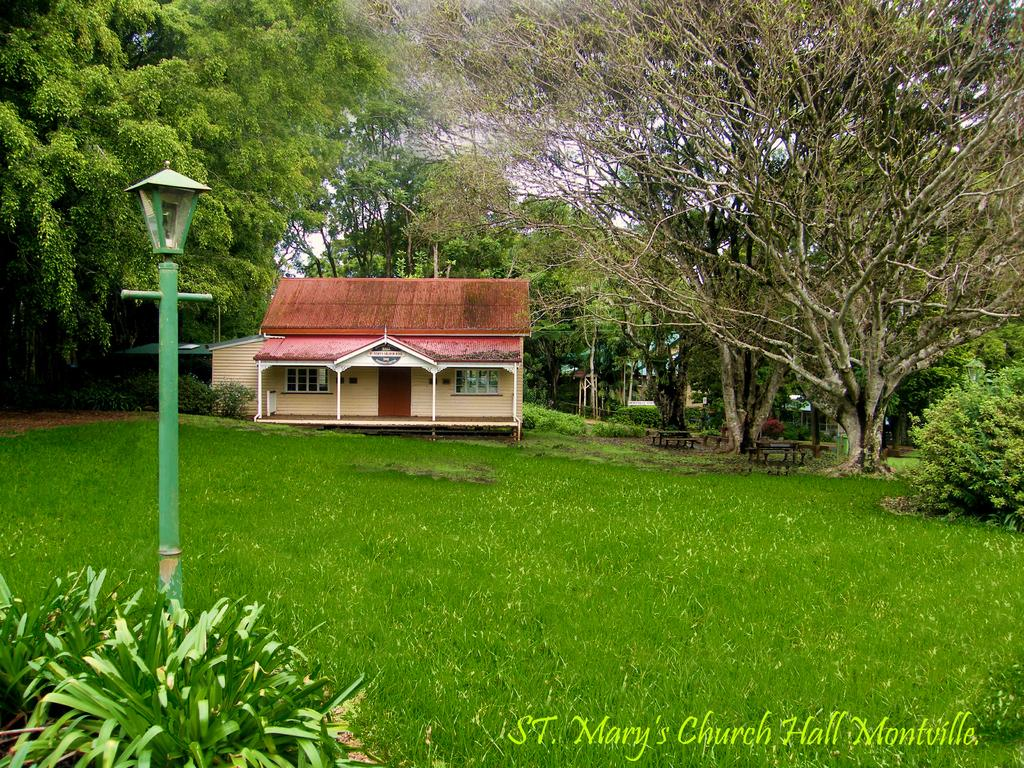What type of structures can be seen in the image? There are houses in the image. What type of vegetation is present in the image? There are trees, plants, and grass in the image. What type of seating is available in the image? There are benches in the image. What type of vertical structures can be seen in the image? There are poles in the image. What type of openings can be seen in the structures? There are windows in the image. What type of illumination is present in the image? There is a light in the image. What can be seen in the background of the image? The sky is visible in the background of the image. What type of cake is being served on the voyage in the image? There is no cake or voyage present in the image. What shape does the circle of trees form in the image? There is no circle of trees in the image; the trees are scattered throughout. 